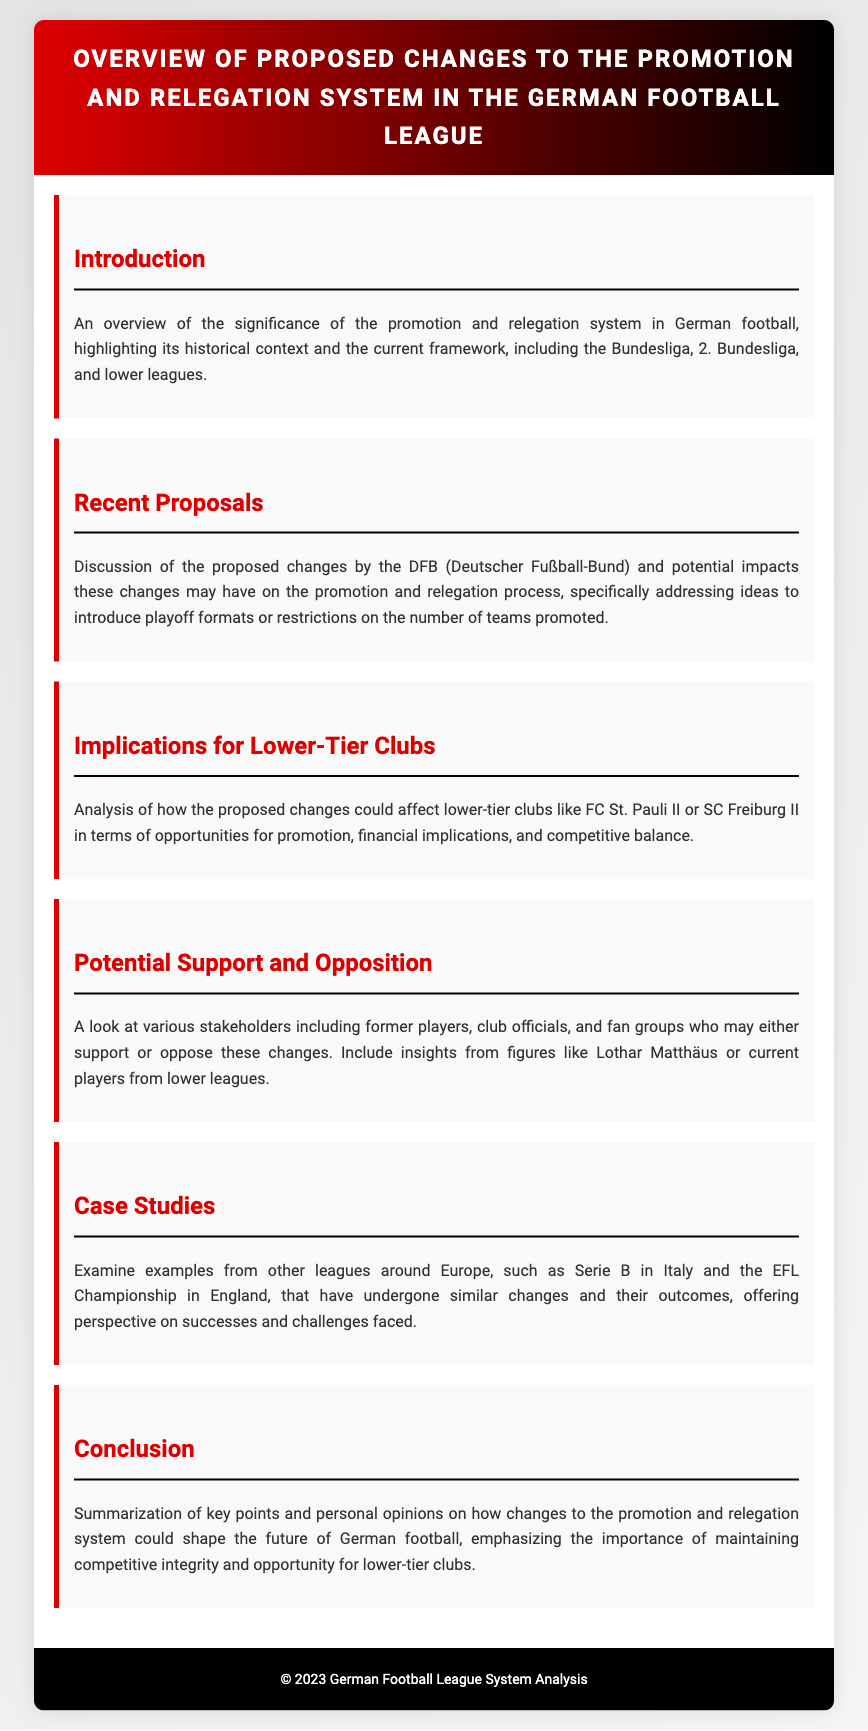What is the title of the document? The title is found in the header section of the document, providing the main subject of discussion.
Answer: Overview of Proposed Changes to the Promotion and Relegation System in the German Football League What does the acronym DFB stand for? The document mentions DFB in the context of proposed changes to the promotion and relegation process, indicating its role in German football.
Answer: Deutscher Fußball-Bund Which club is mentioned as an example of a lower-tier club? The section discussing implications for lower-tier clubs mentions specific teams to illustrate the potential impacts of changes.
Answer: FC St. Pauli II What is one potential change discussed regarding promotion? The document outlines proposed changes that could alter the current promotion and relegation system in German football.
Answer: Playoff formats Who are mentioned as possible supporters or opponents of the changes? The document discusses various stakeholders that may have differing opinions on the proposed changes, indicating engagement within the football community.
Answer: Former players, club officials, fan groups Which league's changes are compared to the proposed German changes? The document includes a section on case studies that look at other leagues to draw comparisons to the German system.
Answer: Serie B in Italy What does the conclusion emphasize regarding lower-tier clubs? The conclusion section summarizes key points while stressing important aspects related to lower-tier clubs and the proposed changes.
Answer: Competitive integrity and opportunity What color is used for the header background? The design of the document incorporates specific colors for different sections, contributing to its aesthetic appeal.
Answer: Red to black gradient 